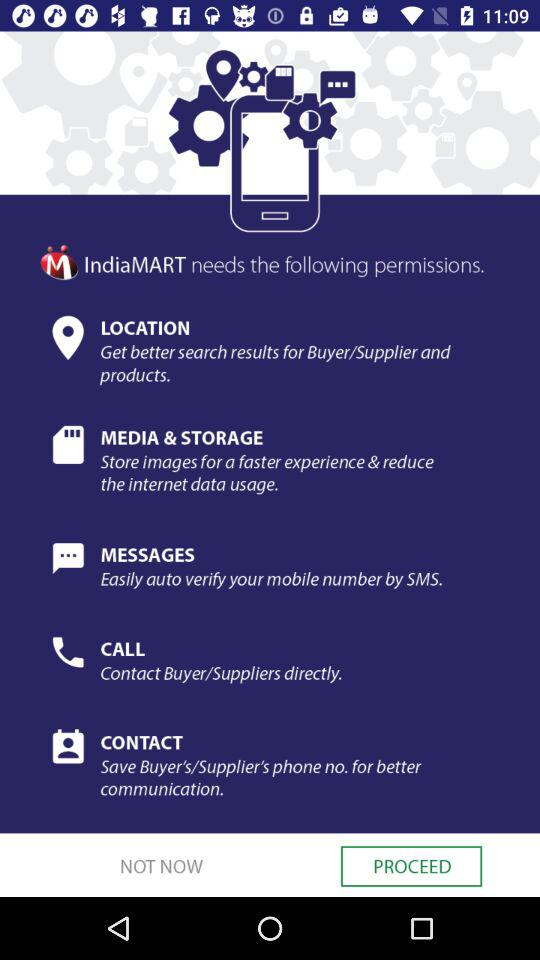What is the application name? The application name is "IndiaMART". 